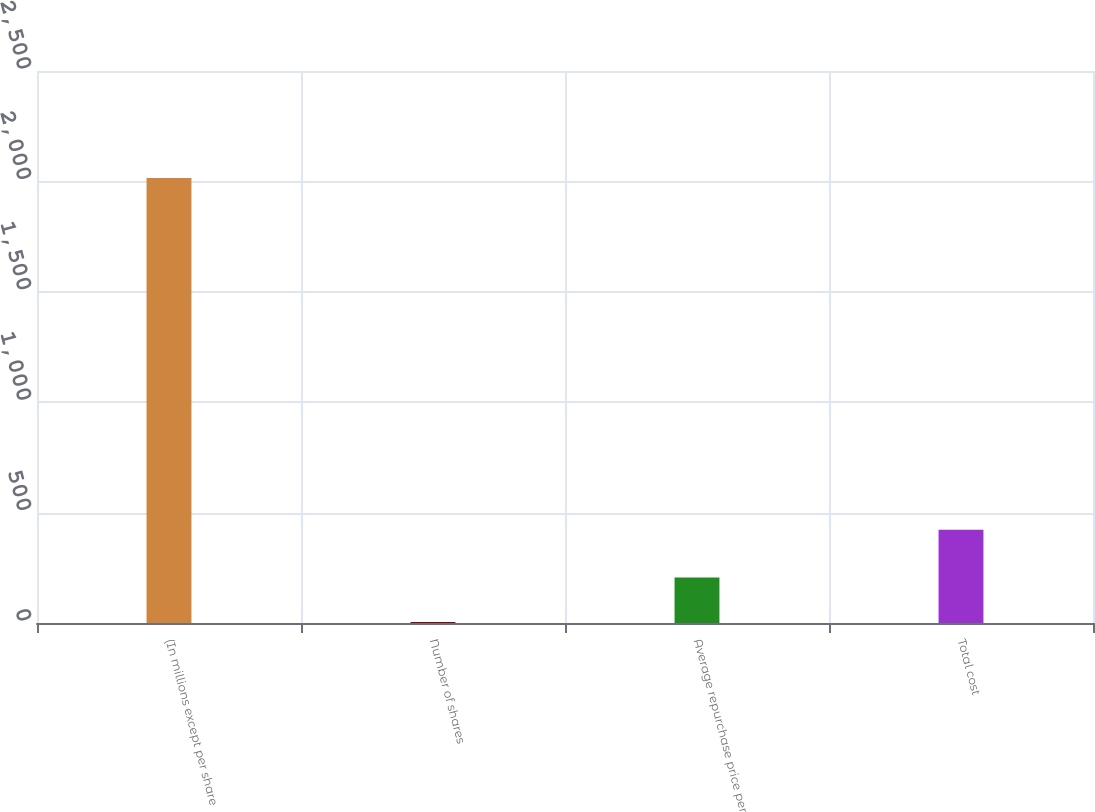Convert chart. <chart><loc_0><loc_0><loc_500><loc_500><bar_chart><fcel>(In millions except per share<fcel>Number of shares<fcel>Average repurchase price per<fcel>Total cost<nl><fcel>2015<fcel>4.8<fcel>205.82<fcel>422<nl></chart> 